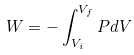<formula> <loc_0><loc_0><loc_500><loc_500>W = - \int _ { V _ { i } } ^ { V _ { f } } P d V</formula> 